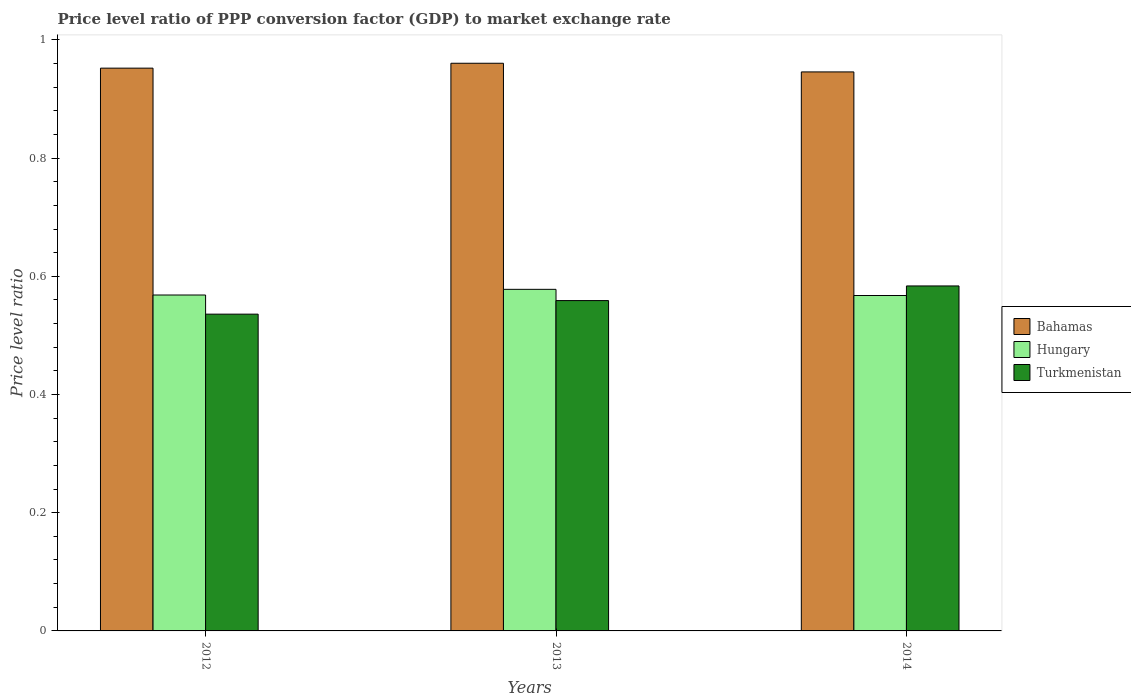How many different coloured bars are there?
Provide a succinct answer. 3. How many groups of bars are there?
Offer a terse response. 3. Are the number of bars per tick equal to the number of legend labels?
Your answer should be very brief. Yes. How many bars are there on the 2nd tick from the right?
Your response must be concise. 3. What is the price level ratio in Turkmenistan in 2013?
Give a very brief answer. 0.56. Across all years, what is the maximum price level ratio in Hungary?
Keep it short and to the point. 0.58. Across all years, what is the minimum price level ratio in Turkmenistan?
Provide a short and direct response. 0.54. What is the total price level ratio in Hungary in the graph?
Offer a very short reply. 1.71. What is the difference between the price level ratio in Turkmenistan in 2012 and that in 2014?
Your response must be concise. -0.05. What is the difference between the price level ratio in Hungary in 2014 and the price level ratio in Turkmenistan in 2012?
Provide a short and direct response. 0.03. What is the average price level ratio in Hungary per year?
Make the answer very short. 0.57. In the year 2014, what is the difference between the price level ratio in Bahamas and price level ratio in Hungary?
Ensure brevity in your answer.  0.38. In how many years, is the price level ratio in Bahamas greater than 0.9600000000000001?
Offer a terse response. 1. What is the ratio of the price level ratio in Bahamas in 2012 to that in 2014?
Your answer should be compact. 1.01. Is the difference between the price level ratio in Bahamas in 2012 and 2014 greater than the difference between the price level ratio in Hungary in 2012 and 2014?
Make the answer very short. Yes. What is the difference between the highest and the second highest price level ratio in Bahamas?
Your answer should be very brief. 0.01. What is the difference between the highest and the lowest price level ratio in Bahamas?
Offer a terse response. 0.01. In how many years, is the price level ratio in Hungary greater than the average price level ratio in Hungary taken over all years?
Your answer should be compact. 1. What does the 2nd bar from the left in 2012 represents?
Offer a terse response. Hungary. What does the 3rd bar from the right in 2014 represents?
Your answer should be very brief. Bahamas. How many bars are there?
Your answer should be compact. 9. How many years are there in the graph?
Provide a short and direct response. 3. What is the difference between two consecutive major ticks on the Y-axis?
Your answer should be compact. 0.2. Are the values on the major ticks of Y-axis written in scientific E-notation?
Give a very brief answer. No. How many legend labels are there?
Provide a succinct answer. 3. How are the legend labels stacked?
Offer a very short reply. Vertical. What is the title of the graph?
Your answer should be compact. Price level ratio of PPP conversion factor (GDP) to market exchange rate. Does "St. Kitts and Nevis" appear as one of the legend labels in the graph?
Your answer should be very brief. No. What is the label or title of the Y-axis?
Offer a very short reply. Price level ratio. What is the Price level ratio of Bahamas in 2012?
Offer a very short reply. 0.95. What is the Price level ratio in Hungary in 2012?
Offer a very short reply. 0.57. What is the Price level ratio in Turkmenistan in 2012?
Offer a very short reply. 0.54. What is the Price level ratio of Bahamas in 2013?
Keep it short and to the point. 0.96. What is the Price level ratio of Hungary in 2013?
Give a very brief answer. 0.58. What is the Price level ratio in Turkmenistan in 2013?
Your response must be concise. 0.56. What is the Price level ratio in Bahamas in 2014?
Ensure brevity in your answer.  0.95. What is the Price level ratio in Hungary in 2014?
Provide a short and direct response. 0.57. What is the Price level ratio of Turkmenistan in 2014?
Keep it short and to the point. 0.58. Across all years, what is the maximum Price level ratio in Bahamas?
Provide a succinct answer. 0.96. Across all years, what is the maximum Price level ratio of Hungary?
Your answer should be compact. 0.58. Across all years, what is the maximum Price level ratio in Turkmenistan?
Your answer should be compact. 0.58. Across all years, what is the minimum Price level ratio of Bahamas?
Offer a very short reply. 0.95. Across all years, what is the minimum Price level ratio of Hungary?
Make the answer very short. 0.57. Across all years, what is the minimum Price level ratio in Turkmenistan?
Provide a short and direct response. 0.54. What is the total Price level ratio of Bahamas in the graph?
Provide a short and direct response. 2.86. What is the total Price level ratio of Hungary in the graph?
Keep it short and to the point. 1.71. What is the total Price level ratio of Turkmenistan in the graph?
Offer a very short reply. 1.68. What is the difference between the Price level ratio of Bahamas in 2012 and that in 2013?
Provide a succinct answer. -0.01. What is the difference between the Price level ratio in Hungary in 2012 and that in 2013?
Provide a succinct answer. -0.01. What is the difference between the Price level ratio of Turkmenistan in 2012 and that in 2013?
Offer a very short reply. -0.02. What is the difference between the Price level ratio of Bahamas in 2012 and that in 2014?
Offer a very short reply. 0.01. What is the difference between the Price level ratio in Hungary in 2012 and that in 2014?
Your response must be concise. 0. What is the difference between the Price level ratio of Turkmenistan in 2012 and that in 2014?
Keep it short and to the point. -0.05. What is the difference between the Price level ratio in Bahamas in 2013 and that in 2014?
Your response must be concise. 0.01. What is the difference between the Price level ratio in Hungary in 2013 and that in 2014?
Offer a very short reply. 0.01. What is the difference between the Price level ratio in Turkmenistan in 2013 and that in 2014?
Keep it short and to the point. -0.02. What is the difference between the Price level ratio in Bahamas in 2012 and the Price level ratio in Hungary in 2013?
Make the answer very short. 0.37. What is the difference between the Price level ratio in Bahamas in 2012 and the Price level ratio in Turkmenistan in 2013?
Offer a very short reply. 0.39. What is the difference between the Price level ratio in Hungary in 2012 and the Price level ratio in Turkmenistan in 2013?
Your response must be concise. 0.01. What is the difference between the Price level ratio of Bahamas in 2012 and the Price level ratio of Hungary in 2014?
Keep it short and to the point. 0.38. What is the difference between the Price level ratio in Bahamas in 2012 and the Price level ratio in Turkmenistan in 2014?
Your answer should be very brief. 0.37. What is the difference between the Price level ratio of Hungary in 2012 and the Price level ratio of Turkmenistan in 2014?
Provide a succinct answer. -0.02. What is the difference between the Price level ratio in Bahamas in 2013 and the Price level ratio in Hungary in 2014?
Make the answer very short. 0.39. What is the difference between the Price level ratio of Bahamas in 2013 and the Price level ratio of Turkmenistan in 2014?
Make the answer very short. 0.38. What is the difference between the Price level ratio in Hungary in 2013 and the Price level ratio in Turkmenistan in 2014?
Provide a succinct answer. -0.01. What is the average Price level ratio of Bahamas per year?
Ensure brevity in your answer.  0.95. What is the average Price level ratio of Hungary per year?
Your response must be concise. 0.57. What is the average Price level ratio of Turkmenistan per year?
Your answer should be compact. 0.56. In the year 2012, what is the difference between the Price level ratio of Bahamas and Price level ratio of Hungary?
Your response must be concise. 0.38. In the year 2012, what is the difference between the Price level ratio of Bahamas and Price level ratio of Turkmenistan?
Your response must be concise. 0.42. In the year 2012, what is the difference between the Price level ratio of Hungary and Price level ratio of Turkmenistan?
Provide a succinct answer. 0.03. In the year 2013, what is the difference between the Price level ratio of Bahamas and Price level ratio of Hungary?
Your response must be concise. 0.38. In the year 2013, what is the difference between the Price level ratio of Bahamas and Price level ratio of Turkmenistan?
Provide a short and direct response. 0.4. In the year 2013, what is the difference between the Price level ratio in Hungary and Price level ratio in Turkmenistan?
Ensure brevity in your answer.  0.02. In the year 2014, what is the difference between the Price level ratio of Bahamas and Price level ratio of Hungary?
Make the answer very short. 0.38. In the year 2014, what is the difference between the Price level ratio in Bahamas and Price level ratio in Turkmenistan?
Your response must be concise. 0.36. In the year 2014, what is the difference between the Price level ratio in Hungary and Price level ratio in Turkmenistan?
Your response must be concise. -0.02. What is the ratio of the Price level ratio of Hungary in 2012 to that in 2013?
Give a very brief answer. 0.98. What is the ratio of the Price level ratio of Turkmenistan in 2012 to that in 2013?
Make the answer very short. 0.96. What is the ratio of the Price level ratio in Hungary in 2012 to that in 2014?
Make the answer very short. 1. What is the ratio of the Price level ratio of Turkmenistan in 2012 to that in 2014?
Offer a very short reply. 0.92. What is the ratio of the Price level ratio in Bahamas in 2013 to that in 2014?
Your response must be concise. 1.02. What is the ratio of the Price level ratio in Hungary in 2013 to that in 2014?
Your answer should be very brief. 1.02. What is the ratio of the Price level ratio in Turkmenistan in 2013 to that in 2014?
Give a very brief answer. 0.96. What is the difference between the highest and the second highest Price level ratio of Bahamas?
Offer a terse response. 0.01. What is the difference between the highest and the second highest Price level ratio of Hungary?
Provide a succinct answer. 0.01. What is the difference between the highest and the second highest Price level ratio in Turkmenistan?
Ensure brevity in your answer.  0.02. What is the difference between the highest and the lowest Price level ratio of Bahamas?
Give a very brief answer. 0.01. What is the difference between the highest and the lowest Price level ratio of Hungary?
Provide a succinct answer. 0.01. What is the difference between the highest and the lowest Price level ratio of Turkmenistan?
Offer a very short reply. 0.05. 